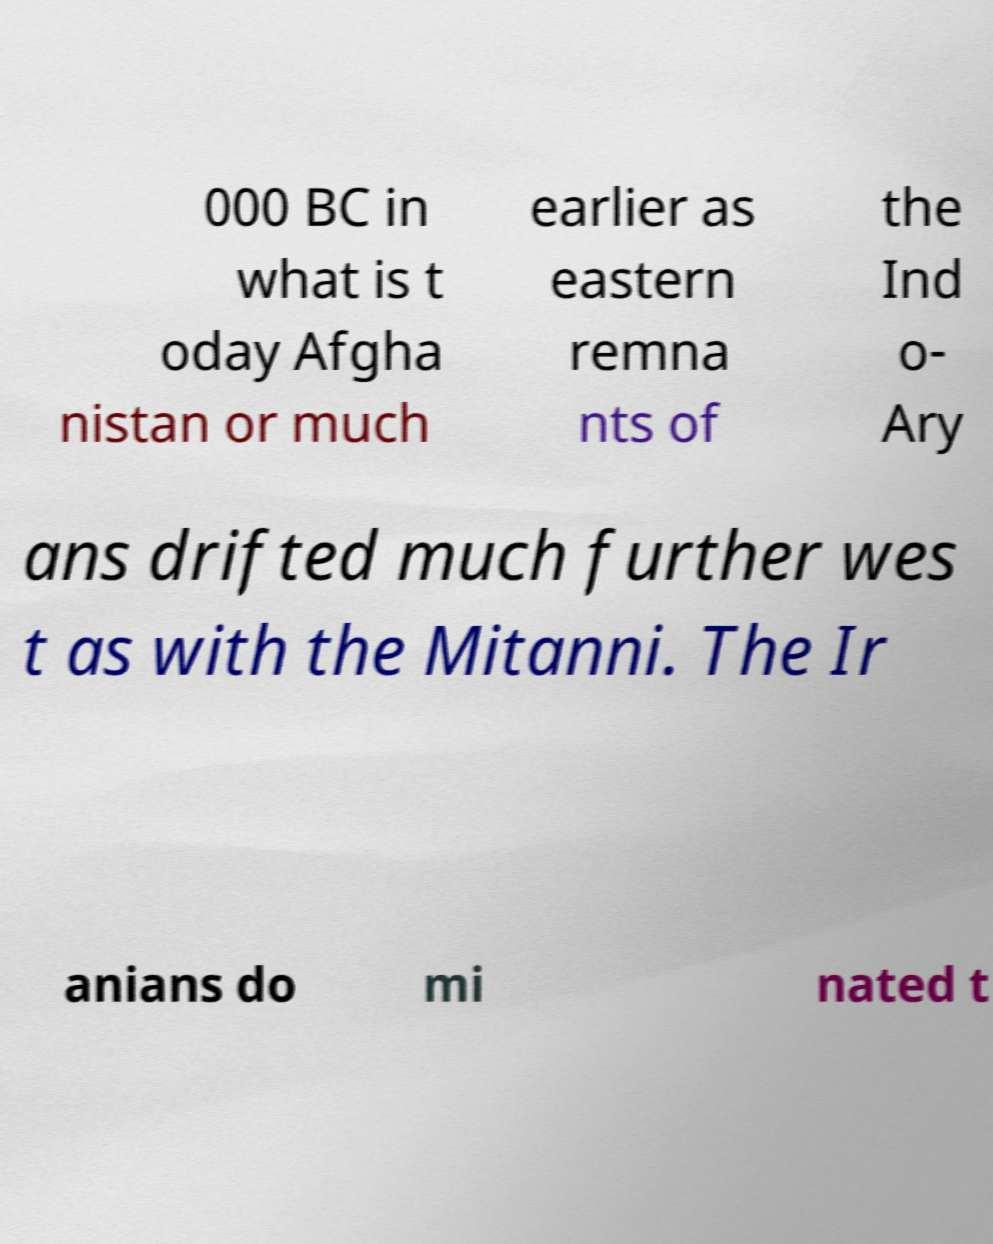Please read and relay the text visible in this image. What does it say? 000 BC in what is t oday Afgha nistan or much earlier as eastern remna nts of the Ind o- Ary ans drifted much further wes t as with the Mitanni. The Ir anians do mi nated t 